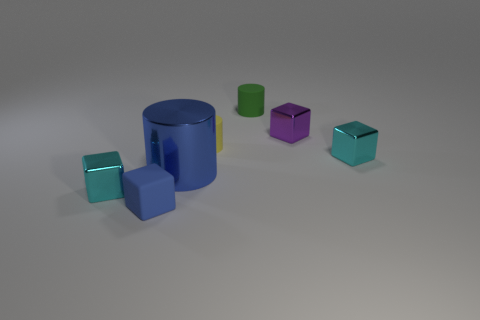There is another small cylinder that is made of the same material as the yellow cylinder; what color is it? There is no other small cylinder made of the same material as the yellow cylinder in the image, as there is only one cylinder present, which is blue with a yellow stripe. 